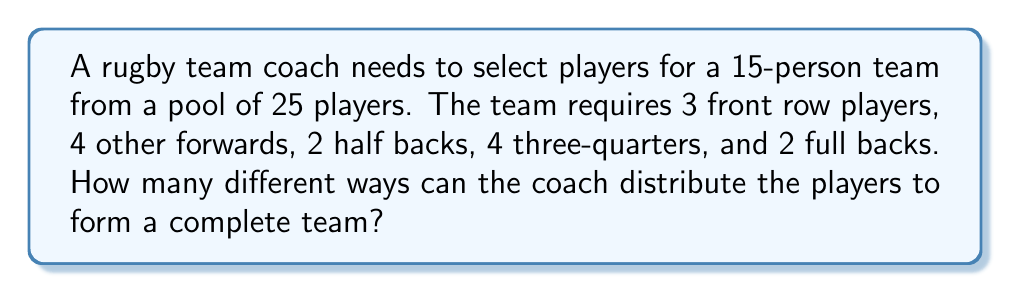Could you help me with this problem? Let's approach this step-by-step using the multiplication principle of combinatorics:

1) For the front row, we need to choose 3 players out of 25:
   $${25 \choose 3} = \frac{25!}{3!(25-3)!} = 2300$$

2) For the other forwards, we choose 4 out of the remaining 22:
   $${22 \choose 4} = \frac{22!}{4!(22-4)!} = 7315$$

3) For half backs, we choose 2 out of the remaining 18:
   $${18 \choose 2} = \frac{18!}{2!(18-2)!} = 153$$

4) For three-quarters, we choose 4 out of the remaining 16:
   $${16 \choose 4} = \frac{16!}{4!(16-4)!} = 1820$$

5) For full backs, we choose 2 out of the remaining 12:
   $${12 \choose 2} = \frac{12!}{2!(12-2)!} = 66$$

6) By the multiplication principle, the total number of ways to distribute the players is the product of all these combinations:

   $$2300 \times 7315 \times 153 \times 1820 \times 66$$

7) Calculating this product:
   $$2300 \times 7315 \times 153 \times 1820 \times 66 = 3,954,824,848,800,000$$
Answer: 3,954,824,848,800,000 